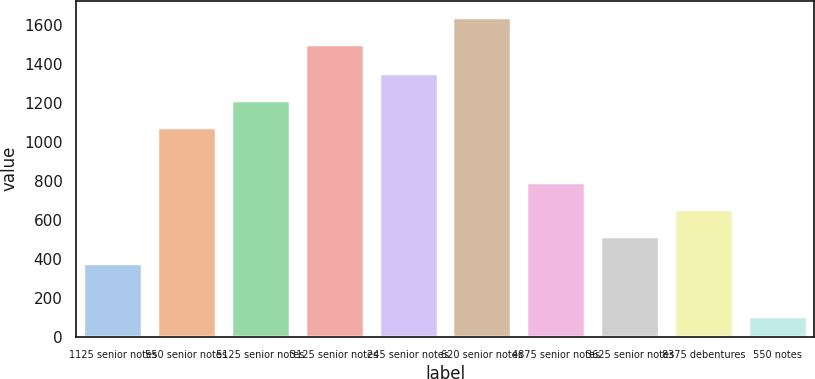Convert chart to OTSL. <chart><loc_0><loc_0><loc_500><loc_500><bar_chart><fcel>1125 senior notes<fcel>550 senior notes<fcel>5125 senior notes<fcel>3125 senior notes<fcel>245 senior notes<fcel>620 senior notes<fcel>4875 senior notes<fcel>3625 senior notes<fcel>8375 debentures<fcel>550 notes<nl><fcel>375<fcel>1073.5<fcel>1213.2<fcel>1500<fcel>1352.9<fcel>1639.7<fcel>794.1<fcel>514.7<fcel>654.4<fcel>103<nl></chart> 